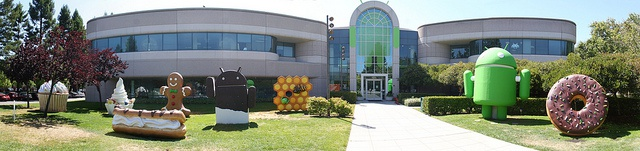Describe the objects in this image and their specific colors. I can see donut in lightblue, brown, black, and maroon tones, hot dog in lightblue, darkgray, gray, and black tones, cake in lightblue, gray, olive, black, and darkgray tones, cake in lightblue, darkgray, lightgray, black, and gray tones, and car in lightblue, black, gray, and blue tones in this image. 